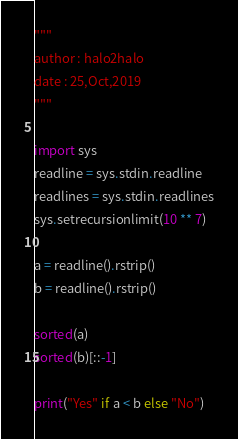<code> <loc_0><loc_0><loc_500><loc_500><_Python_>"""
author : halo2halo
date : 25,Oct,2019
"""

import sys
readline = sys.stdin.readline
readlines = sys.stdin.readlines
sys.setrecursionlimit(10 ** 7)

a = readline().rstrip()
b = readline().rstrip()

sorted(a)
sorted(b)[::-1]

print("Yes" if a < b else "No")
</code> 